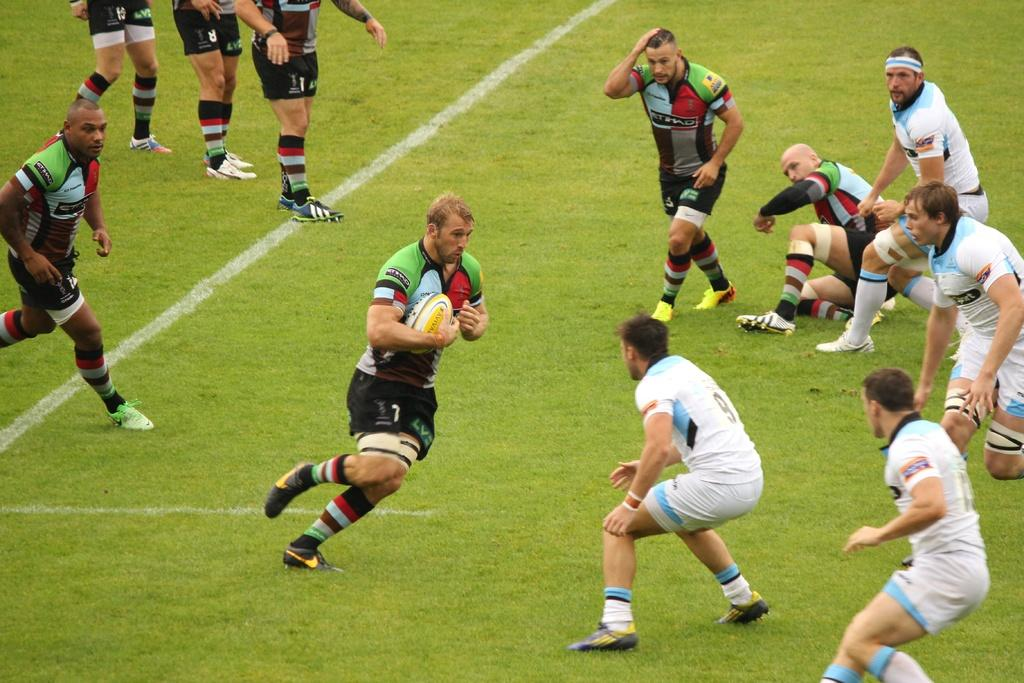What is happening in the image involving the group of people? The people are standing on grass and running, as indicated by leg movement. What might be the reason for the group of people running in the image? It is not explicitly stated, but they could be participating in a sport or game, as one man is holding a ball. Can you describe the setting of the image? The people are standing on grass, which suggests an outdoor or park setting. What type of leather is visible on the airplane in the image? There is no airplane present in the image, and therefore no leather can be observed. 